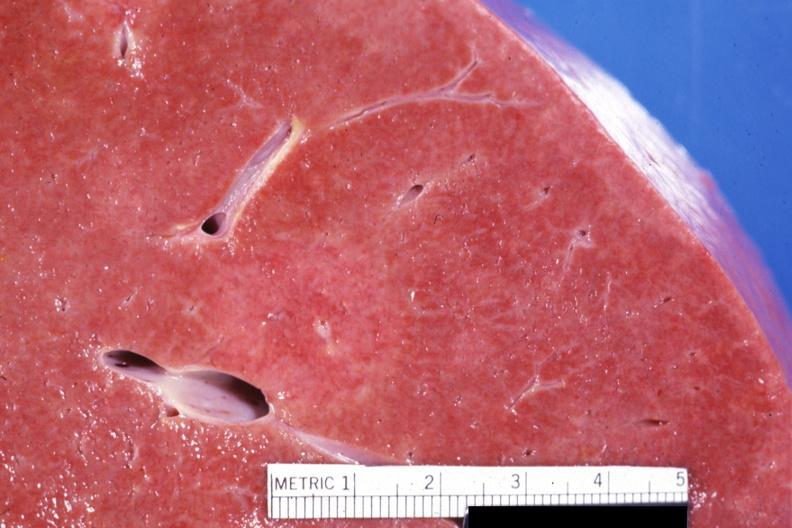what is present?
Answer the question using a single word or phrase. Hepatobiliary 